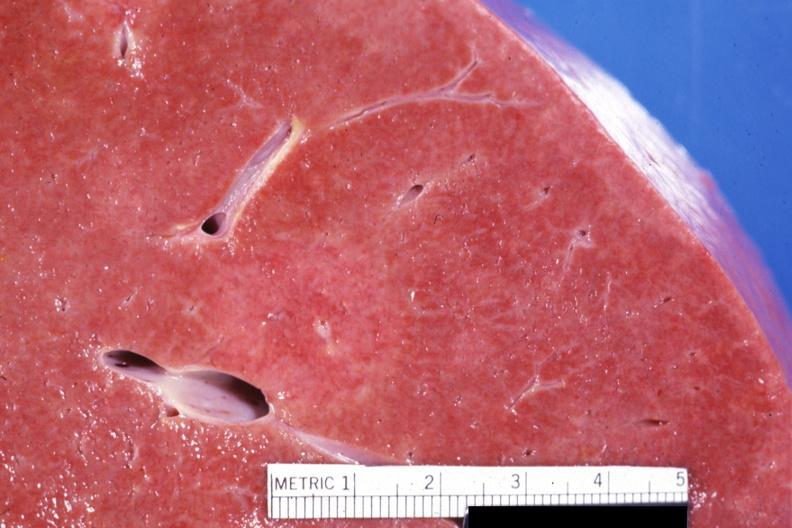what is present?
Answer the question using a single word or phrase. Hepatobiliary 